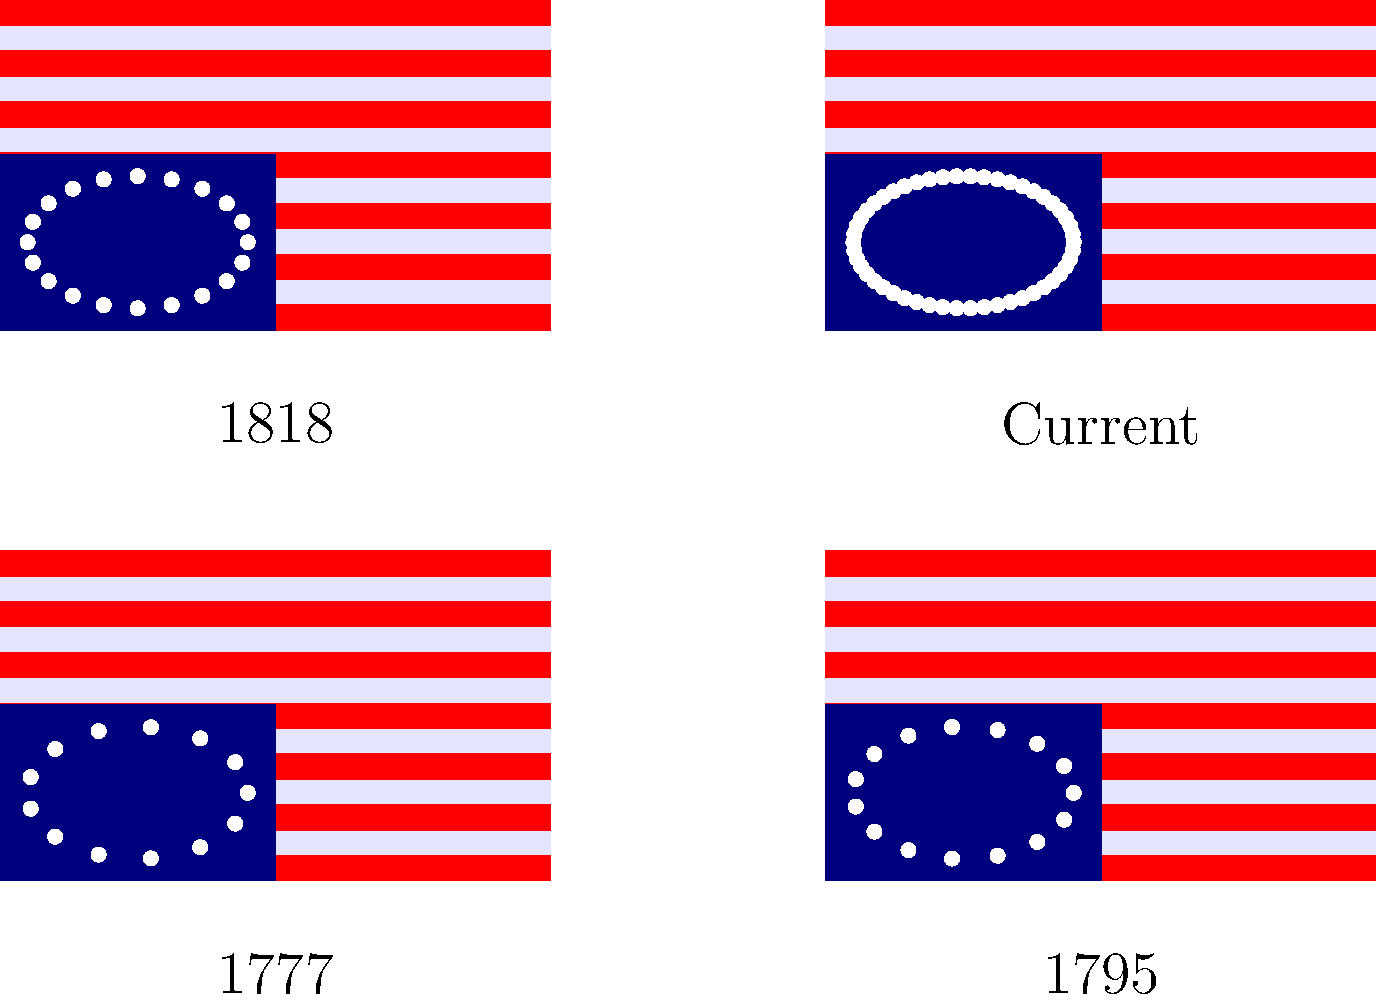Based on the visual representation of the U.S. flag's evolution, which significant historical event likely influenced the change between the 1795 and 1818 versions of the flag? To answer this question, let's analyze the changes in the flag design:

1. The 1777 flag shows 13 stars, representing the original 13 colonies.

2. The 1795 flag has 15 stars, indicating that two new states had joined the Union between 1777 and 1795.

3. The 1818 flag shows a significant increase to 20 stars, suggesting that five more states had been admitted to the Union between 1795 and 1818.

4. The current flag has 50 stars, representing all current states.

The most significant change occurred between 1795 and 1818, with an increase of 5 stars. This period coincides with the aftermath of a major historical event: the War of 1812 (1812-1815).

After the War of 1812:
- The United States experienced a surge of nationalism and westward expansion.
- Several new states were admitted to the Union in quick succession.
- The Flag Act of 1818 was passed, which standardized the flag design and specified that a new star would be added for each new state.

Therefore, the War of 1812 and its aftermath likely influenced the significant change in the flag design between 1795 and 1818, as it led to increased nationalism, westward expansion, and the admission of new states to the Union.
Answer: The War of 1812 and its aftermath 